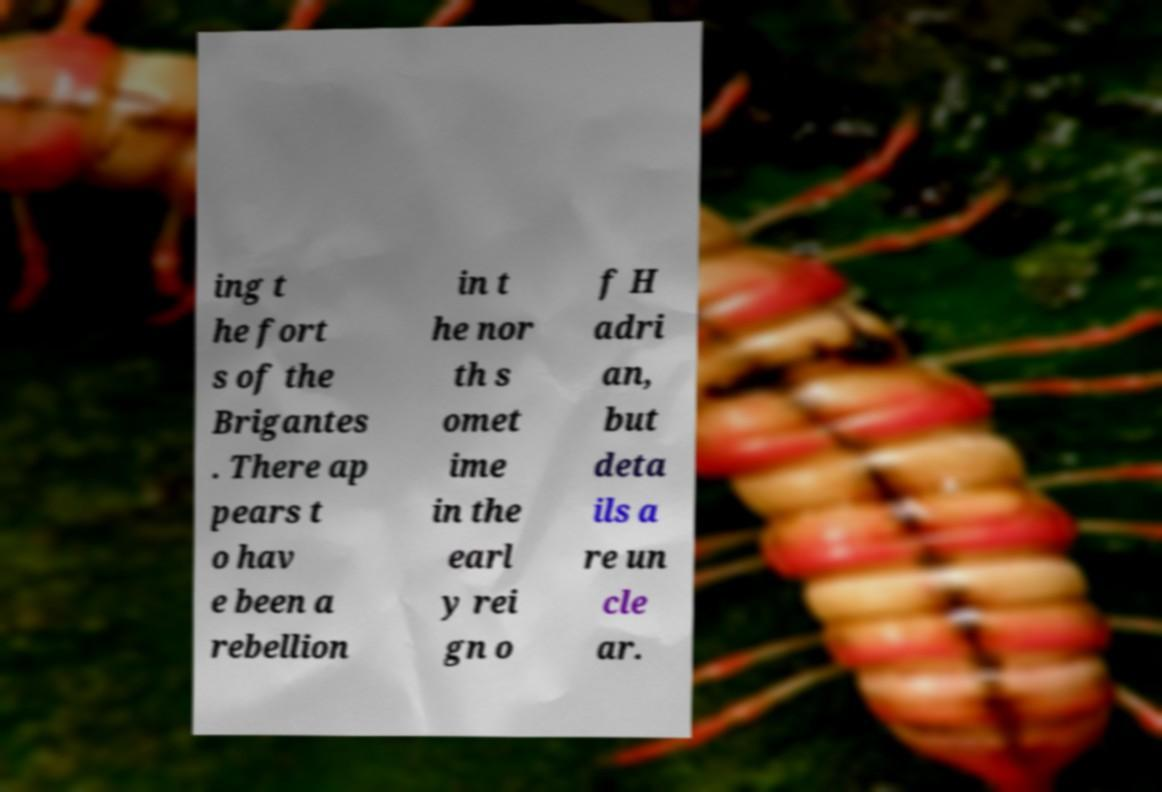Could you assist in decoding the text presented in this image and type it out clearly? ing t he fort s of the Brigantes . There ap pears t o hav e been a rebellion in t he nor th s omet ime in the earl y rei gn o f H adri an, but deta ils a re un cle ar. 